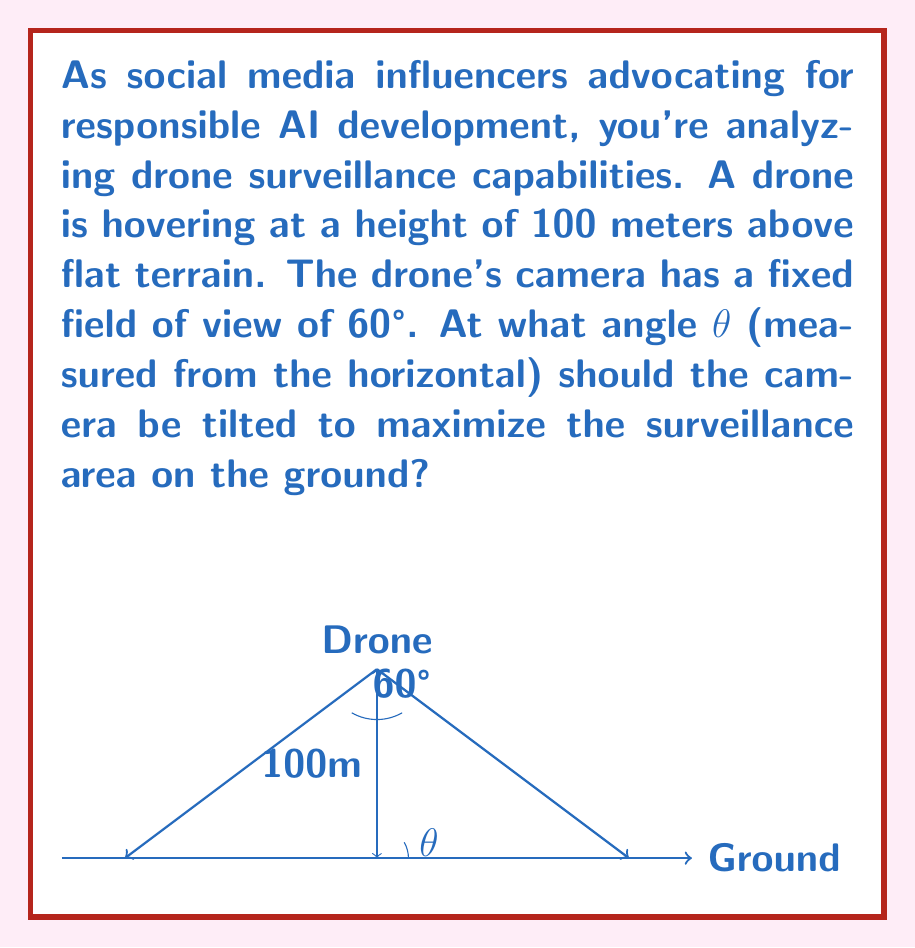Help me with this question. Let's approach this step-by-step:

1) The surveillance area on the ground will be a trapezoid. To maximize this area, we need to position the camera so that the far edge of the field of view just touches the horizon.

2) Let's consider a right triangle formed by the drone's position, the point directly below it on the ground, and the far edge of the field of view.

3) In this triangle:
   - The hypotenuse is the far edge of the camera's field of view
   - One angle is θ (the tilt angle we're looking for)
   - The other angle is half of the camera's field of view: 60°/2 = 30°

4) For the area to be maximized, these two angles must add up to 90°:

   $$ \theta + 30° = 90° $$

5) Solving for θ:

   $$ \theta = 90° - 30° = 60° $$

6) We can verify this geometrically. If the camera is tilted at 60° from the horizontal, its central axis will be perpendicular to the far edge of its field of view, ensuring that this edge just touches the horizon.

7) This angle will maximize the surveillance area regardless of the drone's height, as long as the terrain is flat.
Answer: 60° 